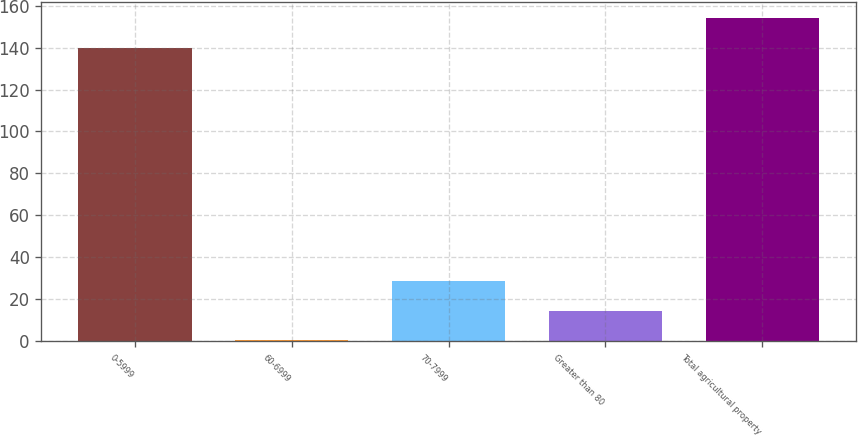Convert chart to OTSL. <chart><loc_0><loc_0><loc_500><loc_500><bar_chart><fcel>0-5999<fcel>60-6999<fcel>70-7999<fcel>Greater than 80<fcel>Total agricultural property<nl><fcel>140<fcel>0.79<fcel>28.63<fcel>14.71<fcel>153.92<nl></chart> 